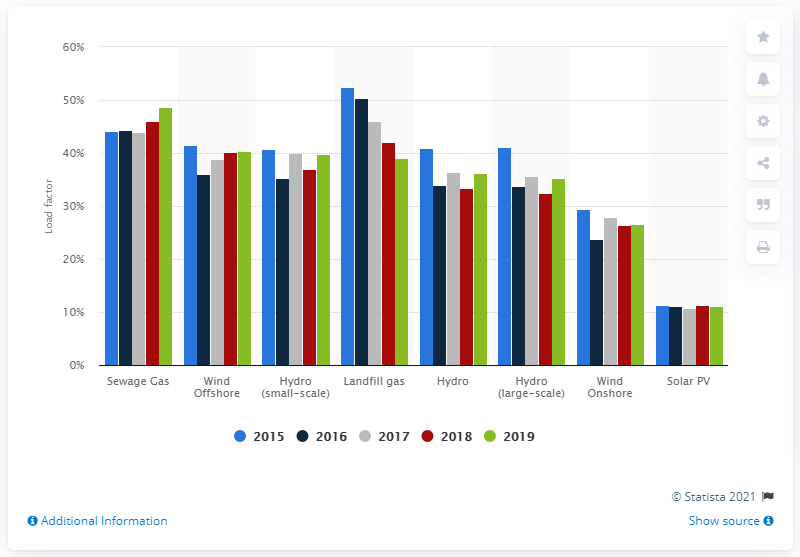Identify some key points in this picture. The load factor of sewer gas in 2019 was 48.6%. 